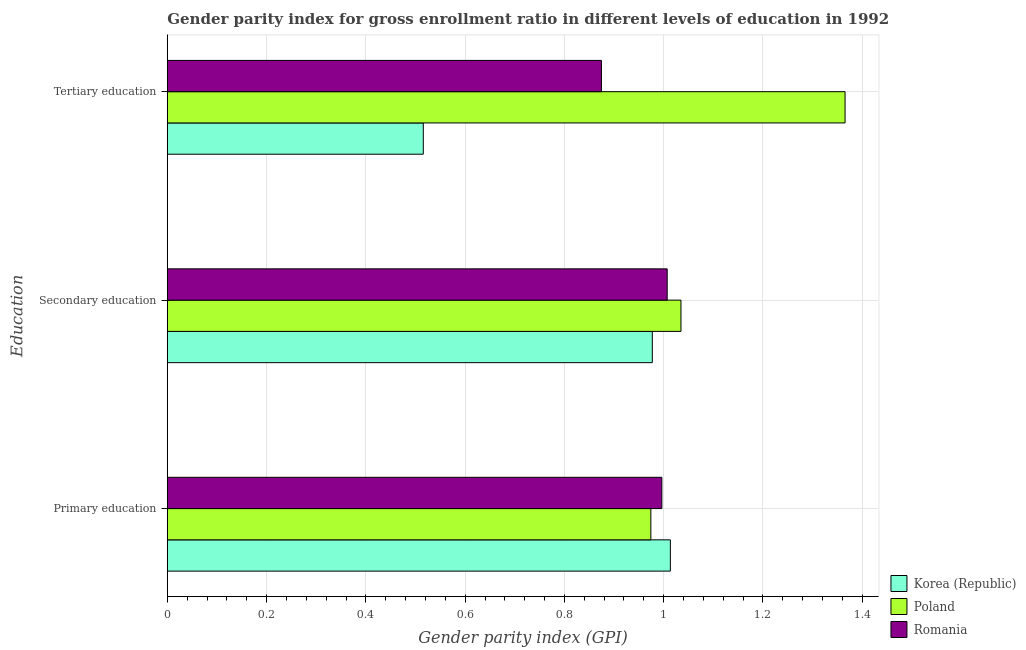Are the number of bars on each tick of the Y-axis equal?
Your answer should be very brief. Yes. How many bars are there on the 2nd tick from the top?
Your response must be concise. 3. What is the label of the 3rd group of bars from the top?
Offer a very short reply. Primary education. What is the gender parity index in tertiary education in Korea (Republic)?
Offer a terse response. 0.52. Across all countries, what is the maximum gender parity index in tertiary education?
Your answer should be very brief. 1.37. Across all countries, what is the minimum gender parity index in secondary education?
Your answer should be compact. 0.98. In which country was the gender parity index in primary education maximum?
Offer a terse response. Korea (Republic). In which country was the gender parity index in secondary education minimum?
Offer a terse response. Korea (Republic). What is the total gender parity index in primary education in the graph?
Give a very brief answer. 2.98. What is the difference between the gender parity index in secondary education in Romania and that in Korea (Republic)?
Provide a short and direct response. 0.03. What is the difference between the gender parity index in tertiary education in Korea (Republic) and the gender parity index in primary education in Poland?
Provide a short and direct response. -0.46. What is the average gender parity index in tertiary education per country?
Your answer should be very brief. 0.92. What is the difference between the gender parity index in secondary education and gender parity index in primary education in Poland?
Your answer should be compact. 0.06. In how many countries, is the gender parity index in primary education greater than 0.92 ?
Ensure brevity in your answer.  3. What is the ratio of the gender parity index in tertiary education in Romania to that in Poland?
Offer a terse response. 0.64. Is the difference between the gender parity index in tertiary education in Korea (Republic) and Romania greater than the difference between the gender parity index in primary education in Korea (Republic) and Romania?
Offer a very short reply. No. What is the difference between the highest and the second highest gender parity index in tertiary education?
Give a very brief answer. 0.49. What is the difference between the highest and the lowest gender parity index in secondary education?
Your response must be concise. 0.06. In how many countries, is the gender parity index in tertiary education greater than the average gender parity index in tertiary education taken over all countries?
Ensure brevity in your answer.  1. Is the sum of the gender parity index in primary education in Poland and Romania greater than the maximum gender parity index in tertiary education across all countries?
Ensure brevity in your answer.  Yes. What does the 3rd bar from the bottom in Primary education represents?
Ensure brevity in your answer.  Romania. How many bars are there?
Give a very brief answer. 9. Are all the bars in the graph horizontal?
Keep it short and to the point. Yes. How many countries are there in the graph?
Offer a terse response. 3. What is the difference between two consecutive major ticks on the X-axis?
Provide a succinct answer. 0.2. Are the values on the major ticks of X-axis written in scientific E-notation?
Make the answer very short. No. Where does the legend appear in the graph?
Keep it short and to the point. Bottom right. What is the title of the graph?
Your answer should be very brief. Gender parity index for gross enrollment ratio in different levels of education in 1992. What is the label or title of the X-axis?
Provide a short and direct response. Gender parity index (GPI). What is the label or title of the Y-axis?
Keep it short and to the point. Education. What is the Gender parity index (GPI) of Korea (Republic) in Primary education?
Offer a very short reply. 1.01. What is the Gender parity index (GPI) of Poland in Primary education?
Your response must be concise. 0.97. What is the Gender parity index (GPI) of Romania in Primary education?
Provide a succinct answer. 1. What is the Gender parity index (GPI) in Korea (Republic) in Secondary education?
Offer a very short reply. 0.98. What is the Gender parity index (GPI) in Poland in Secondary education?
Give a very brief answer. 1.03. What is the Gender parity index (GPI) in Romania in Secondary education?
Your answer should be compact. 1.01. What is the Gender parity index (GPI) in Korea (Republic) in Tertiary education?
Provide a short and direct response. 0.52. What is the Gender parity index (GPI) of Poland in Tertiary education?
Your answer should be very brief. 1.37. What is the Gender parity index (GPI) of Romania in Tertiary education?
Give a very brief answer. 0.87. Across all Education, what is the maximum Gender parity index (GPI) in Korea (Republic)?
Offer a terse response. 1.01. Across all Education, what is the maximum Gender parity index (GPI) in Poland?
Ensure brevity in your answer.  1.37. Across all Education, what is the maximum Gender parity index (GPI) in Romania?
Provide a succinct answer. 1.01. Across all Education, what is the minimum Gender parity index (GPI) of Korea (Republic)?
Make the answer very short. 0.52. Across all Education, what is the minimum Gender parity index (GPI) in Poland?
Ensure brevity in your answer.  0.97. Across all Education, what is the minimum Gender parity index (GPI) of Romania?
Your answer should be very brief. 0.87. What is the total Gender parity index (GPI) of Korea (Republic) in the graph?
Ensure brevity in your answer.  2.51. What is the total Gender parity index (GPI) of Poland in the graph?
Your answer should be compact. 3.37. What is the total Gender parity index (GPI) of Romania in the graph?
Offer a terse response. 2.88. What is the difference between the Gender parity index (GPI) of Korea (Republic) in Primary education and that in Secondary education?
Your answer should be compact. 0.04. What is the difference between the Gender parity index (GPI) of Poland in Primary education and that in Secondary education?
Your response must be concise. -0.06. What is the difference between the Gender parity index (GPI) of Romania in Primary education and that in Secondary education?
Provide a short and direct response. -0.01. What is the difference between the Gender parity index (GPI) in Korea (Republic) in Primary education and that in Tertiary education?
Provide a succinct answer. 0.5. What is the difference between the Gender parity index (GPI) in Poland in Primary education and that in Tertiary education?
Ensure brevity in your answer.  -0.39. What is the difference between the Gender parity index (GPI) in Romania in Primary education and that in Tertiary education?
Keep it short and to the point. 0.12. What is the difference between the Gender parity index (GPI) of Korea (Republic) in Secondary education and that in Tertiary education?
Provide a succinct answer. 0.46. What is the difference between the Gender parity index (GPI) in Poland in Secondary education and that in Tertiary education?
Provide a short and direct response. -0.33. What is the difference between the Gender parity index (GPI) in Romania in Secondary education and that in Tertiary education?
Provide a short and direct response. 0.13. What is the difference between the Gender parity index (GPI) of Korea (Republic) in Primary education and the Gender parity index (GPI) of Poland in Secondary education?
Give a very brief answer. -0.02. What is the difference between the Gender parity index (GPI) in Korea (Republic) in Primary education and the Gender parity index (GPI) in Romania in Secondary education?
Make the answer very short. 0.01. What is the difference between the Gender parity index (GPI) in Poland in Primary education and the Gender parity index (GPI) in Romania in Secondary education?
Your response must be concise. -0.03. What is the difference between the Gender parity index (GPI) in Korea (Republic) in Primary education and the Gender parity index (GPI) in Poland in Tertiary education?
Provide a succinct answer. -0.35. What is the difference between the Gender parity index (GPI) of Korea (Republic) in Primary education and the Gender parity index (GPI) of Romania in Tertiary education?
Your answer should be compact. 0.14. What is the difference between the Gender parity index (GPI) in Poland in Primary education and the Gender parity index (GPI) in Romania in Tertiary education?
Your answer should be compact. 0.1. What is the difference between the Gender parity index (GPI) in Korea (Republic) in Secondary education and the Gender parity index (GPI) in Poland in Tertiary education?
Offer a terse response. -0.39. What is the difference between the Gender parity index (GPI) in Korea (Republic) in Secondary education and the Gender parity index (GPI) in Romania in Tertiary education?
Give a very brief answer. 0.1. What is the difference between the Gender parity index (GPI) of Poland in Secondary education and the Gender parity index (GPI) of Romania in Tertiary education?
Offer a very short reply. 0.16. What is the average Gender parity index (GPI) in Korea (Republic) per Education?
Offer a very short reply. 0.84. What is the average Gender parity index (GPI) of Poland per Education?
Your answer should be compact. 1.12. What is the average Gender parity index (GPI) of Romania per Education?
Offer a terse response. 0.96. What is the difference between the Gender parity index (GPI) of Korea (Republic) and Gender parity index (GPI) of Poland in Primary education?
Ensure brevity in your answer.  0.04. What is the difference between the Gender parity index (GPI) of Korea (Republic) and Gender parity index (GPI) of Romania in Primary education?
Make the answer very short. 0.02. What is the difference between the Gender parity index (GPI) in Poland and Gender parity index (GPI) in Romania in Primary education?
Ensure brevity in your answer.  -0.02. What is the difference between the Gender parity index (GPI) in Korea (Republic) and Gender parity index (GPI) in Poland in Secondary education?
Provide a succinct answer. -0.06. What is the difference between the Gender parity index (GPI) of Korea (Republic) and Gender parity index (GPI) of Romania in Secondary education?
Provide a short and direct response. -0.03. What is the difference between the Gender parity index (GPI) in Poland and Gender parity index (GPI) in Romania in Secondary education?
Ensure brevity in your answer.  0.03. What is the difference between the Gender parity index (GPI) of Korea (Republic) and Gender parity index (GPI) of Poland in Tertiary education?
Your answer should be compact. -0.85. What is the difference between the Gender parity index (GPI) of Korea (Republic) and Gender parity index (GPI) of Romania in Tertiary education?
Keep it short and to the point. -0.36. What is the difference between the Gender parity index (GPI) in Poland and Gender parity index (GPI) in Romania in Tertiary education?
Your answer should be compact. 0.49. What is the ratio of the Gender parity index (GPI) of Korea (Republic) in Primary education to that in Secondary education?
Your answer should be very brief. 1.04. What is the ratio of the Gender parity index (GPI) in Poland in Primary education to that in Secondary education?
Your answer should be very brief. 0.94. What is the ratio of the Gender parity index (GPI) in Romania in Primary education to that in Secondary education?
Your answer should be very brief. 0.99. What is the ratio of the Gender parity index (GPI) of Korea (Republic) in Primary education to that in Tertiary education?
Give a very brief answer. 1.97. What is the ratio of the Gender parity index (GPI) in Poland in Primary education to that in Tertiary education?
Your answer should be compact. 0.71. What is the ratio of the Gender parity index (GPI) of Romania in Primary education to that in Tertiary education?
Make the answer very short. 1.14. What is the ratio of the Gender parity index (GPI) in Korea (Republic) in Secondary education to that in Tertiary education?
Offer a terse response. 1.89. What is the ratio of the Gender parity index (GPI) in Poland in Secondary education to that in Tertiary education?
Offer a very short reply. 0.76. What is the ratio of the Gender parity index (GPI) of Romania in Secondary education to that in Tertiary education?
Give a very brief answer. 1.15. What is the difference between the highest and the second highest Gender parity index (GPI) of Korea (Republic)?
Offer a very short reply. 0.04. What is the difference between the highest and the second highest Gender parity index (GPI) in Poland?
Your response must be concise. 0.33. What is the difference between the highest and the second highest Gender parity index (GPI) of Romania?
Your response must be concise. 0.01. What is the difference between the highest and the lowest Gender parity index (GPI) in Korea (Republic)?
Ensure brevity in your answer.  0.5. What is the difference between the highest and the lowest Gender parity index (GPI) in Poland?
Your answer should be very brief. 0.39. What is the difference between the highest and the lowest Gender parity index (GPI) of Romania?
Your answer should be very brief. 0.13. 